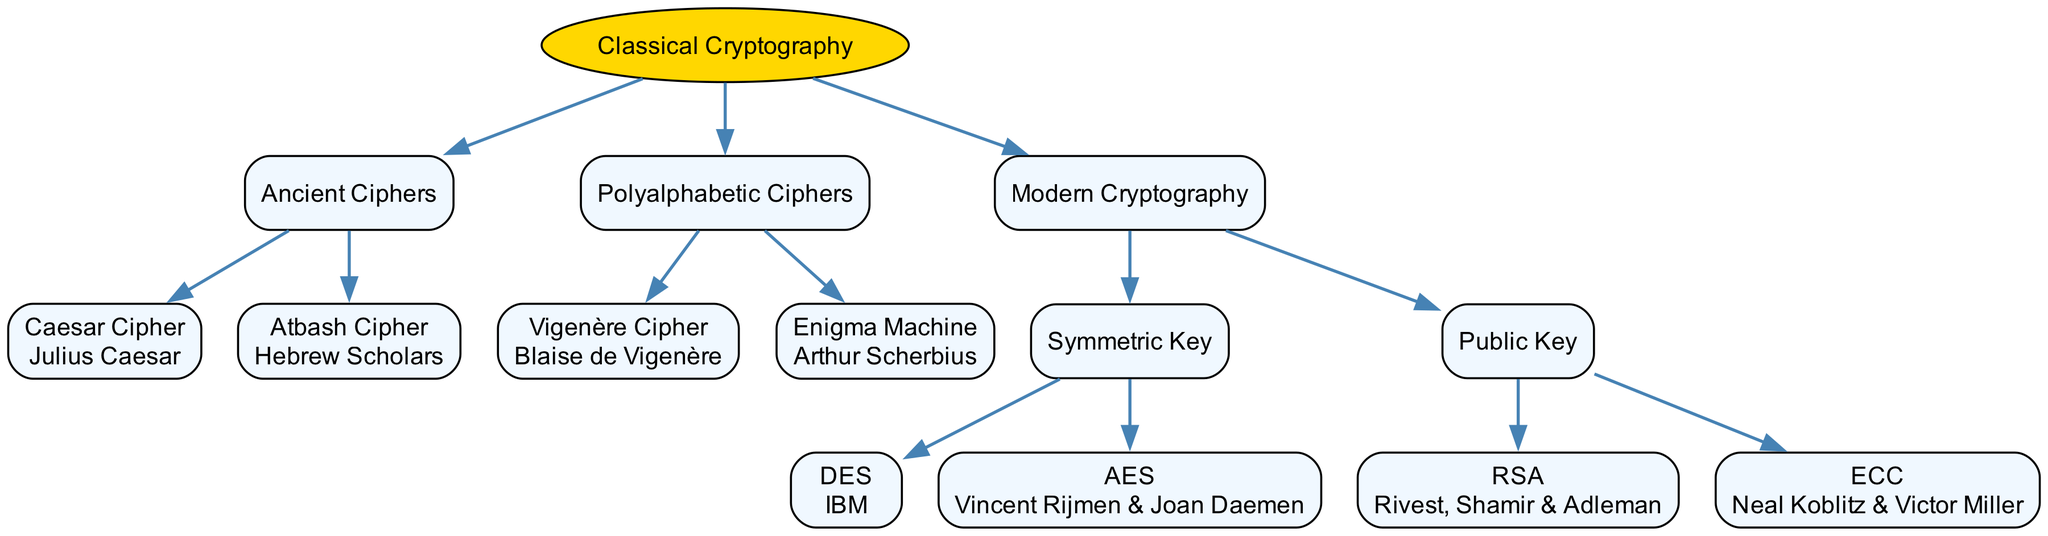What is the root node of the diagram? The root node is "Classical Cryptography", which serves as the top-level category of the diagram. It encapsulates all other nodes as its children.
Answer: Classical Cryptography How many children does "Modern Cryptography" have? The "Modern Cryptography" node has two children: "Symmetric Key" and "Public Key." Therefore, it contains two direct branches.
Answer: 2 Who developed the Vigenère Cipher? The Vigenère Cipher is attributed to Blaise de Vigenère, as indicated in the developer label associated with that cipher in the diagram.
Answer: Blaise de Vigenère What type of cipher is the Enigma Machine categorized under? The Enigma Machine falls under the category of "Polyalphabetic Ciphers," as shown in the hierarchy of the diagram.
Answer: Polyalphabetic Ciphers Which developer is associated with AES? AES is associated with the developers Vincent Rijmen and Joan Daemen, as the diagram specifies their names under the AES node.
Answer: Vincent Rijmen & Joan Daemen How many total methods of cryptography are listed under "Classical Cryptography"? Within the "Classical Cryptography" section, there are three distinct methods listed: "Ancient Ciphers," "Polyalphabetic Ciphers," and "Modern Cryptography." Thus, the total is three methods.
Answer: 3 Which ciphers fall under the category of "Symmetric Key"? The two ciphers categorized under "Symmetric Key" are DES and AES, both of which are direct children of this category.
Answer: DES and AES What is the relationship between the RSA and Public Key? RSA is categorized as a method under the "Public Key" section, making it a child node of "Public Key." This indicates that RSA is a specific type of Public Key cryptography.
Answer: Child node Who are the developers of ECC? The developers of ECC are Neal Koblitz and Victor Miller, explicitly mentioned next to the ECC node in the diagram.
Answer: Neal Koblitz & Victor Miller 